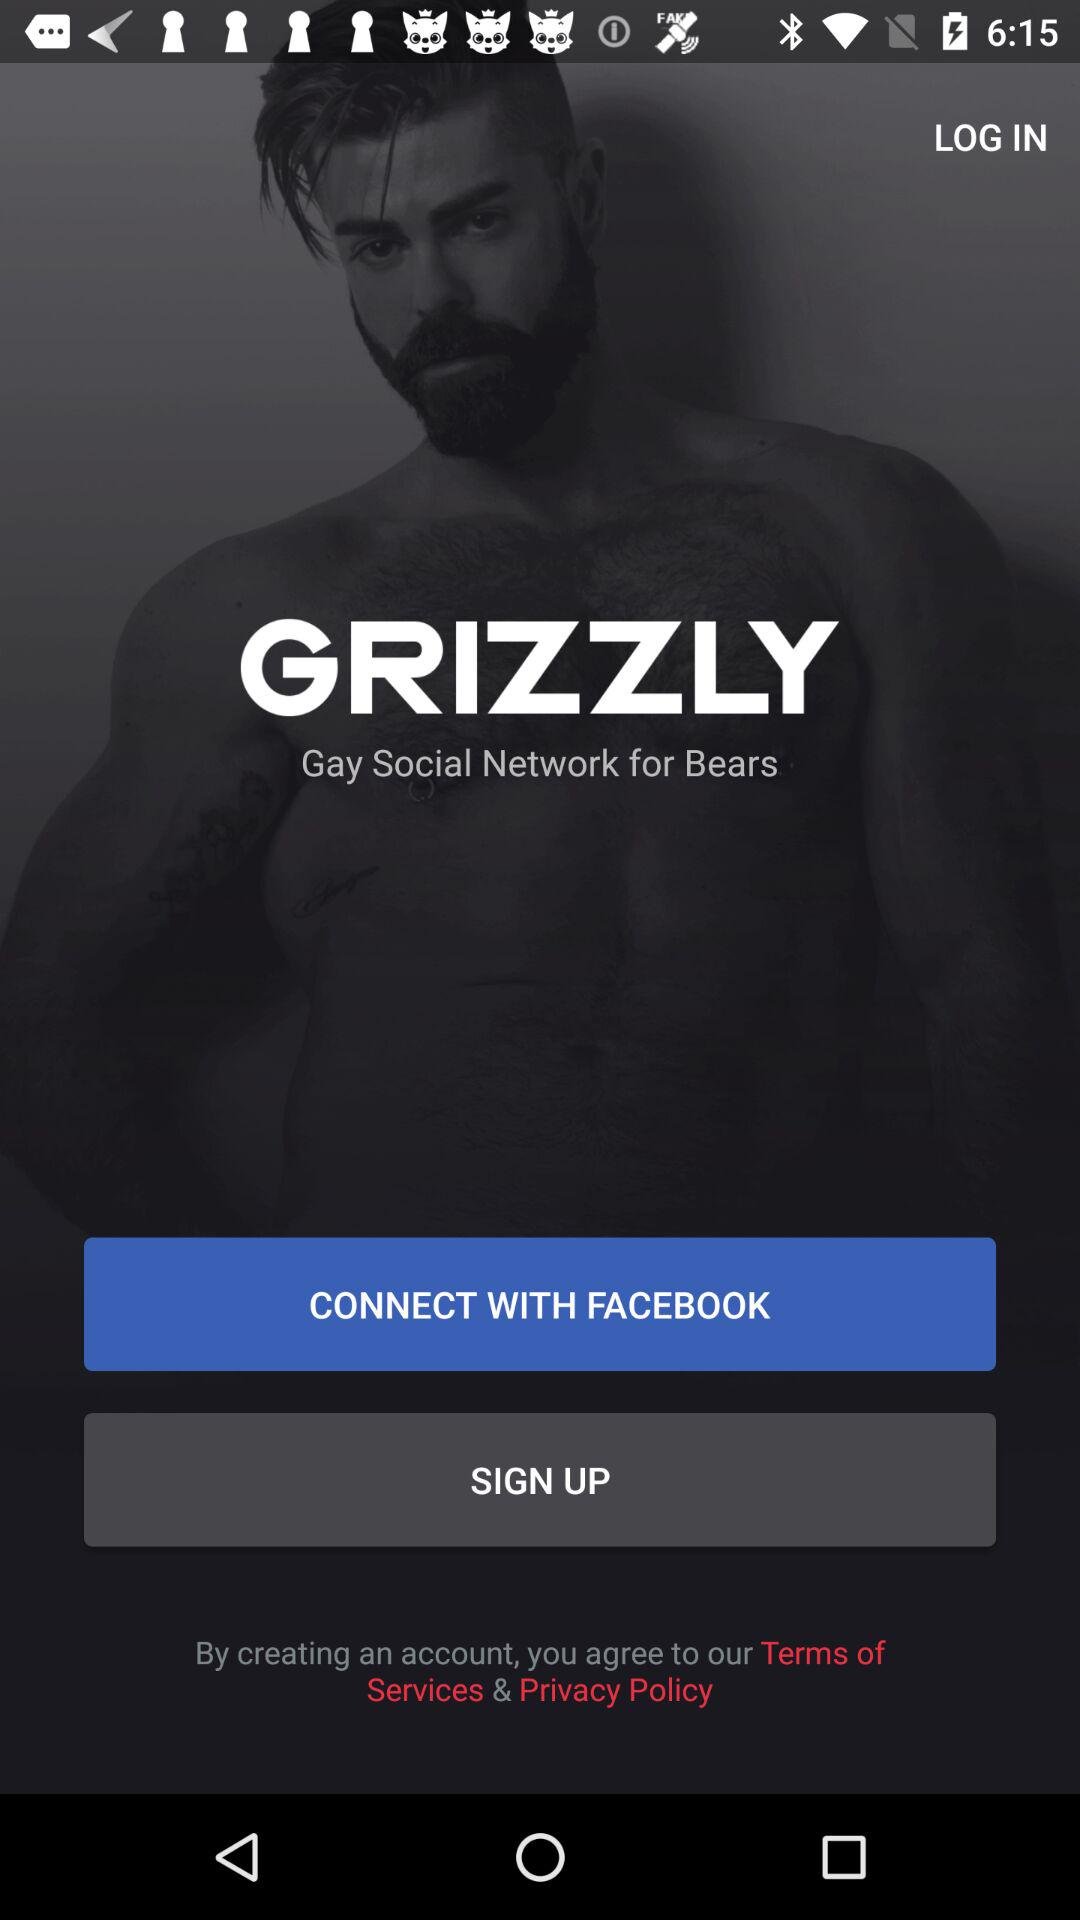What kind of social media network is it? It is a Gay social media network. 